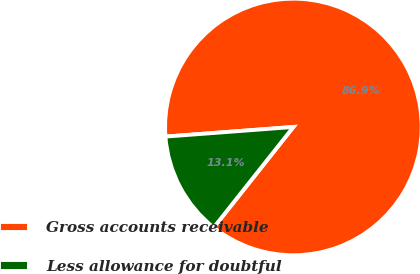Convert chart. <chart><loc_0><loc_0><loc_500><loc_500><pie_chart><fcel>Gross accounts receivable<fcel>Less allowance for doubtful<nl><fcel>86.86%<fcel>13.14%<nl></chart> 